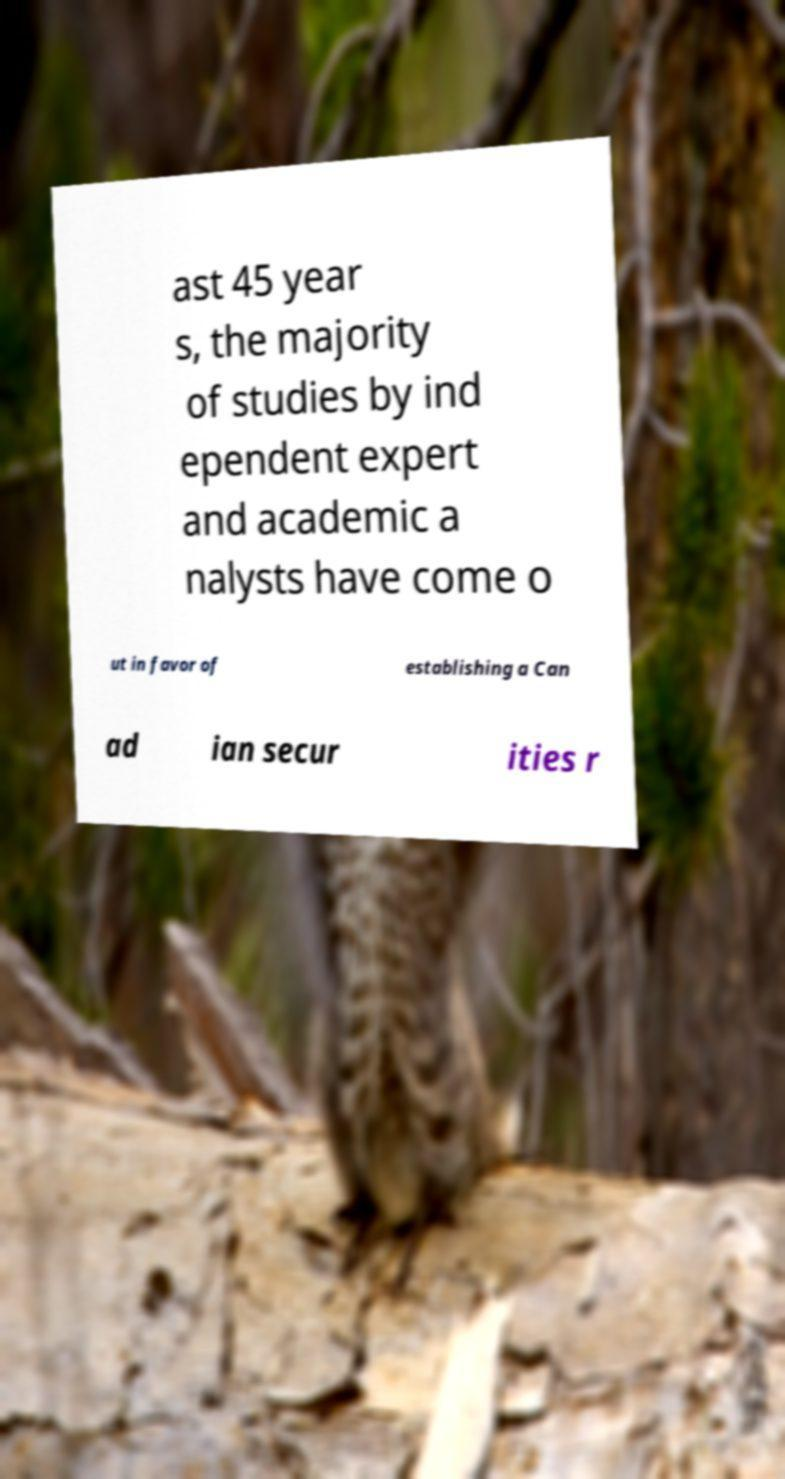Could you extract and type out the text from this image? ast 45 year s, the majority of studies by ind ependent expert and academic a nalysts have come o ut in favor of establishing a Can ad ian secur ities r 